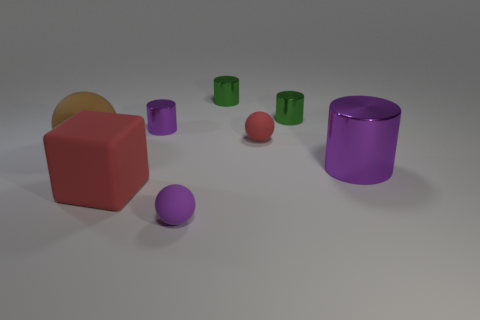There is a large block; does it have the same color as the tiny matte thing behind the big purple cylinder? Yes, the large red block shares the same color as the small matte sphere located behind the big purple cylinder. They both exhibit a similar shade of red, creating a visual connection between the two objects despite their difference in size and texture. 